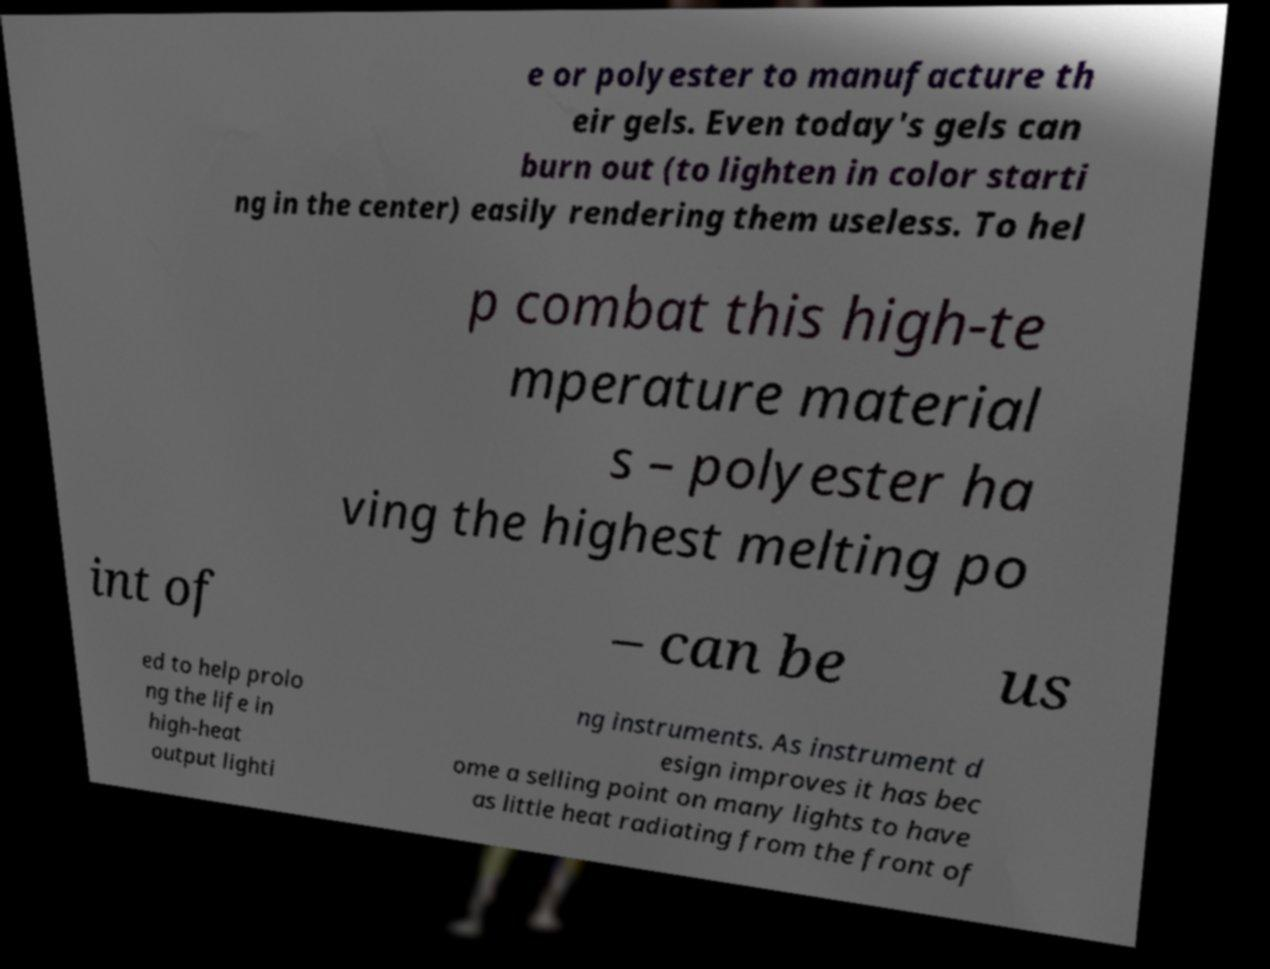For documentation purposes, I need the text within this image transcribed. Could you provide that? e or polyester to manufacture th eir gels. Even today's gels can burn out (to lighten in color starti ng in the center) easily rendering them useless. To hel p combat this high-te mperature material s – polyester ha ving the highest melting po int of – can be us ed to help prolo ng the life in high-heat output lighti ng instruments. As instrument d esign improves it has bec ome a selling point on many lights to have as little heat radiating from the front of 